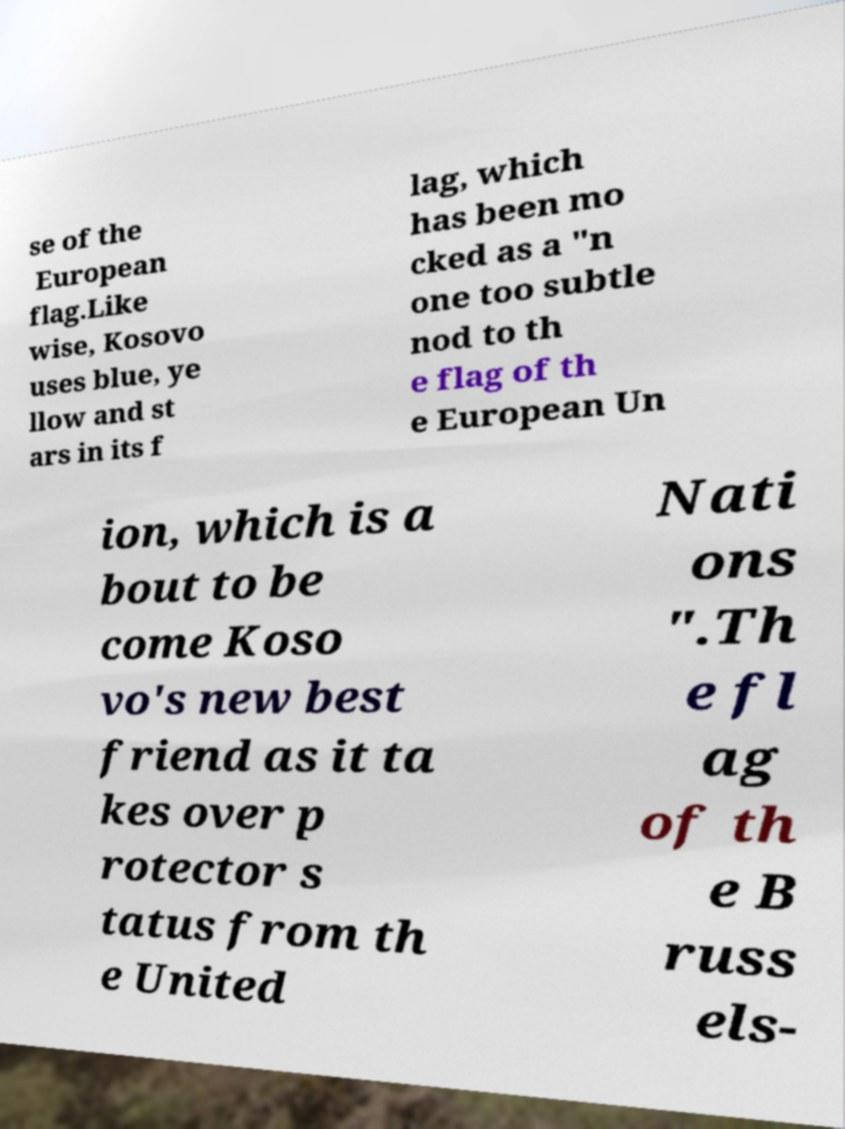There's text embedded in this image that I need extracted. Can you transcribe it verbatim? se of the European flag.Like wise, Kosovo uses blue, ye llow and st ars in its f lag, which has been mo cked as a "n one too subtle nod to th e flag of th e European Un ion, which is a bout to be come Koso vo's new best friend as it ta kes over p rotector s tatus from th e United Nati ons ".Th e fl ag of th e B russ els- 